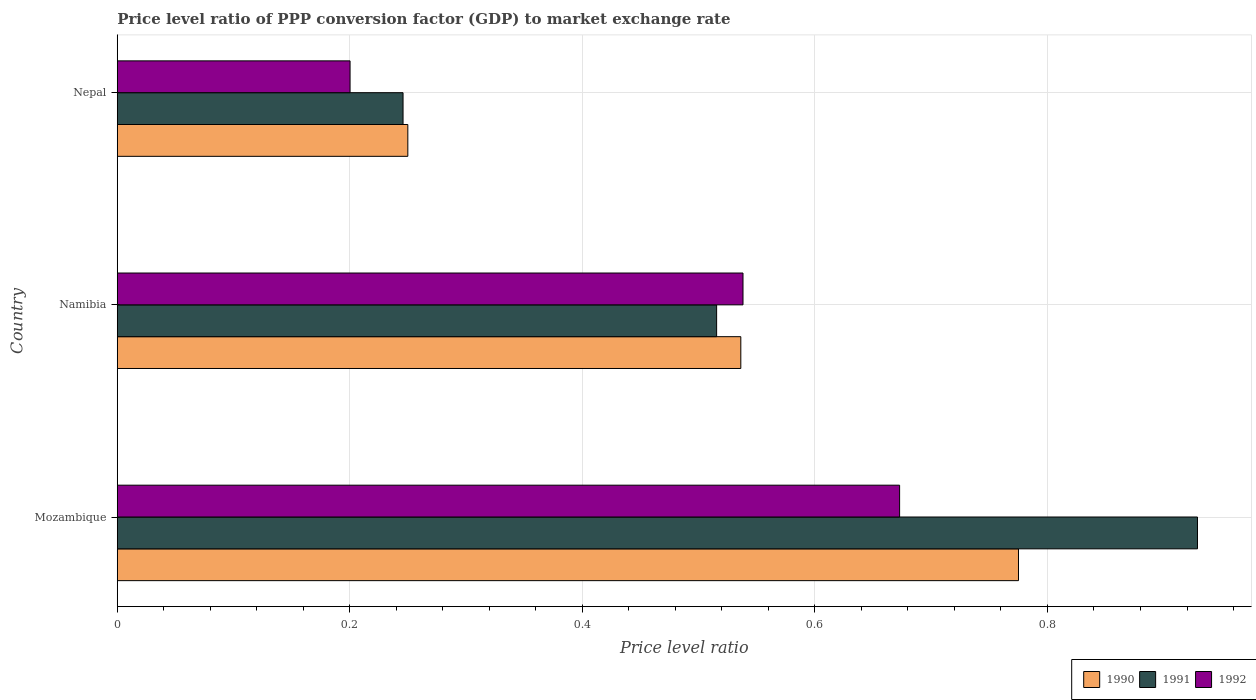How many groups of bars are there?
Your answer should be very brief. 3. Are the number of bars on each tick of the Y-axis equal?
Your answer should be very brief. Yes. How many bars are there on the 3rd tick from the top?
Give a very brief answer. 3. How many bars are there on the 2nd tick from the bottom?
Your answer should be very brief. 3. What is the label of the 2nd group of bars from the top?
Provide a short and direct response. Namibia. What is the price level ratio in 1992 in Nepal?
Ensure brevity in your answer.  0.2. Across all countries, what is the maximum price level ratio in 1990?
Your response must be concise. 0.78. Across all countries, what is the minimum price level ratio in 1990?
Your answer should be very brief. 0.25. In which country was the price level ratio in 1990 maximum?
Provide a short and direct response. Mozambique. In which country was the price level ratio in 1991 minimum?
Keep it short and to the point. Nepal. What is the total price level ratio in 1992 in the graph?
Give a very brief answer. 1.41. What is the difference between the price level ratio in 1990 in Mozambique and that in Nepal?
Offer a very short reply. 0.53. What is the difference between the price level ratio in 1990 in Namibia and the price level ratio in 1991 in Mozambique?
Offer a terse response. -0.39. What is the average price level ratio in 1991 per country?
Your response must be concise. 0.56. What is the difference between the price level ratio in 1991 and price level ratio in 1990 in Nepal?
Offer a terse response. -0. In how many countries, is the price level ratio in 1992 greater than 0.24000000000000002 ?
Provide a short and direct response. 2. What is the ratio of the price level ratio in 1992 in Mozambique to that in Nepal?
Provide a succinct answer. 3.36. Is the difference between the price level ratio in 1991 in Namibia and Nepal greater than the difference between the price level ratio in 1990 in Namibia and Nepal?
Offer a terse response. No. What is the difference between the highest and the second highest price level ratio in 1991?
Keep it short and to the point. 0.41. What is the difference between the highest and the lowest price level ratio in 1992?
Your answer should be compact. 0.47. Is the sum of the price level ratio in 1991 in Mozambique and Nepal greater than the maximum price level ratio in 1990 across all countries?
Keep it short and to the point. Yes. What does the 3rd bar from the bottom in Namibia represents?
Your answer should be compact. 1992. Is it the case that in every country, the sum of the price level ratio in 1991 and price level ratio in 1992 is greater than the price level ratio in 1990?
Offer a very short reply. Yes. How many countries are there in the graph?
Provide a short and direct response. 3. Are the values on the major ticks of X-axis written in scientific E-notation?
Make the answer very short. No. Does the graph contain any zero values?
Make the answer very short. No. Does the graph contain grids?
Make the answer very short. Yes. How many legend labels are there?
Your answer should be compact. 3. How are the legend labels stacked?
Your response must be concise. Horizontal. What is the title of the graph?
Offer a terse response. Price level ratio of PPP conversion factor (GDP) to market exchange rate. Does "2000" appear as one of the legend labels in the graph?
Your answer should be very brief. No. What is the label or title of the X-axis?
Your answer should be compact. Price level ratio. What is the Price level ratio of 1990 in Mozambique?
Your response must be concise. 0.78. What is the Price level ratio of 1991 in Mozambique?
Your response must be concise. 0.93. What is the Price level ratio of 1992 in Mozambique?
Your answer should be compact. 0.67. What is the Price level ratio in 1990 in Namibia?
Keep it short and to the point. 0.54. What is the Price level ratio in 1991 in Namibia?
Give a very brief answer. 0.52. What is the Price level ratio in 1992 in Namibia?
Make the answer very short. 0.54. What is the Price level ratio of 1990 in Nepal?
Ensure brevity in your answer.  0.25. What is the Price level ratio in 1991 in Nepal?
Ensure brevity in your answer.  0.25. What is the Price level ratio of 1992 in Nepal?
Make the answer very short. 0.2. Across all countries, what is the maximum Price level ratio in 1990?
Your answer should be compact. 0.78. Across all countries, what is the maximum Price level ratio in 1991?
Make the answer very short. 0.93. Across all countries, what is the maximum Price level ratio of 1992?
Ensure brevity in your answer.  0.67. Across all countries, what is the minimum Price level ratio of 1990?
Provide a short and direct response. 0.25. Across all countries, what is the minimum Price level ratio in 1991?
Keep it short and to the point. 0.25. Across all countries, what is the minimum Price level ratio of 1992?
Give a very brief answer. 0.2. What is the total Price level ratio in 1990 in the graph?
Your answer should be very brief. 1.56. What is the total Price level ratio in 1991 in the graph?
Keep it short and to the point. 1.69. What is the total Price level ratio in 1992 in the graph?
Your answer should be very brief. 1.41. What is the difference between the Price level ratio of 1990 in Mozambique and that in Namibia?
Your response must be concise. 0.24. What is the difference between the Price level ratio in 1991 in Mozambique and that in Namibia?
Offer a very short reply. 0.41. What is the difference between the Price level ratio of 1992 in Mozambique and that in Namibia?
Keep it short and to the point. 0.13. What is the difference between the Price level ratio of 1990 in Mozambique and that in Nepal?
Offer a terse response. 0.53. What is the difference between the Price level ratio of 1991 in Mozambique and that in Nepal?
Offer a very short reply. 0.68. What is the difference between the Price level ratio of 1992 in Mozambique and that in Nepal?
Provide a short and direct response. 0.47. What is the difference between the Price level ratio in 1990 in Namibia and that in Nepal?
Keep it short and to the point. 0.29. What is the difference between the Price level ratio of 1991 in Namibia and that in Nepal?
Give a very brief answer. 0.27. What is the difference between the Price level ratio of 1992 in Namibia and that in Nepal?
Give a very brief answer. 0.34. What is the difference between the Price level ratio in 1990 in Mozambique and the Price level ratio in 1991 in Namibia?
Your answer should be very brief. 0.26. What is the difference between the Price level ratio in 1990 in Mozambique and the Price level ratio in 1992 in Namibia?
Make the answer very short. 0.24. What is the difference between the Price level ratio in 1991 in Mozambique and the Price level ratio in 1992 in Namibia?
Offer a very short reply. 0.39. What is the difference between the Price level ratio of 1990 in Mozambique and the Price level ratio of 1991 in Nepal?
Give a very brief answer. 0.53. What is the difference between the Price level ratio in 1990 in Mozambique and the Price level ratio in 1992 in Nepal?
Keep it short and to the point. 0.57. What is the difference between the Price level ratio in 1991 in Mozambique and the Price level ratio in 1992 in Nepal?
Your answer should be compact. 0.73. What is the difference between the Price level ratio of 1990 in Namibia and the Price level ratio of 1991 in Nepal?
Ensure brevity in your answer.  0.29. What is the difference between the Price level ratio in 1990 in Namibia and the Price level ratio in 1992 in Nepal?
Offer a terse response. 0.34. What is the difference between the Price level ratio of 1991 in Namibia and the Price level ratio of 1992 in Nepal?
Keep it short and to the point. 0.32. What is the average Price level ratio of 1990 per country?
Your answer should be compact. 0.52. What is the average Price level ratio in 1991 per country?
Make the answer very short. 0.56. What is the average Price level ratio in 1992 per country?
Your response must be concise. 0.47. What is the difference between the Price level ratio in 1990 and Price level ratio in 1991 in Mozambique?
Your response must be concise. -0.15. What is the difference between the Price level ratio of 1990 and Price level ratio of 1992 in Mozambique?
Provide a short and direct response. 0.1. What is the difference between the Price level ratio of 1991 and Price level ratio of 1992 in Mozambique?
Your response must be concise. 0.26. What is the difference between the Price level ratio in 1990 and Price level ratio in 1991 in Namibia?
Give a very brief answer. 0.02. What is the difference between the Price level ratio of 1990 and Price level ratio of 1992 in Namibia?
Your answer should be very brief. -0. What is the difference between the Price level ratio in 1991 and Price level ratio in 1992 in Namibia?
Give a very brief answer. -0.02. What is the difference between the Price level ratio in 1990 and Price level ratio in 1991 in Nepal?
Ensure brevity in your answer.  0. What is the difference between the Price level ratio in 1990 and Price level ratio in 1992 in Nepal?
Offer a terse response. 0.05. What is the difference between the Price level ratio in 1991 and Price level ratio in 1992 in Nepal?
Keep it short and to the point. 0.05. What is the ratio of the Price level ratio in 1990 in Mozambique to that in Namibia?
Keep it short and to the point. 1.45. What is the ratio of the Price level ratio in 1991 in Mozambique to that in Namibia?
Offer a terse response. 1.8. What is the ratio of the Price level ratio in 1992 in Mozambique to that in Namibia?
Offer a very short reply. 1.25. What is the ratio of the Price level ratio in 1990 in Mozambique to that in Nepal?
Provide a short and direct response. 3.1. What is the ratio of the Price level ratio in 1991 in Mozambique to that in Nepal?
Offer a terse response. 3.78. What is the ratio of the Price level ratio in 1992 in Mozambique to that in Nepal?
Keep it short and to the point. 3.36. What is the ratio of the Price level ratio in 1990 in Namibia to that in Nepal?
Provide a short and direct response. 2.15. What is the ratio of the Price level ratio in 1991 in Namibia to that in Nepal?
Keep it short and to the point. 2.1. What is the ratio of the Price level ratio in 1992 in Namibia to that in Nepal?
Keep it short and to the point. 2.69. What is the difference between the highest and the second highest Price level ratio in 1990?
Provide a short and direct response. 0.24. What is the difference between the highest and the second highest Price level ratio of 1991?
Your response must be concise. 0.41. What is the difference between the highest and the second highest Price level ratio of 1992?
Provide a succinct answer. 0.13. What is the difference between the highest and the lowest Price level ratio in 1990?
Provide a succinct answer. 0.53. What is the difference between the highest and the lowest Price level ratio in 1991?
Provide a succinct answer. 0.68. What is the difference between the highest and the lowest Price level ratio in 1992?
Provide a short and direct response. 0.47. 